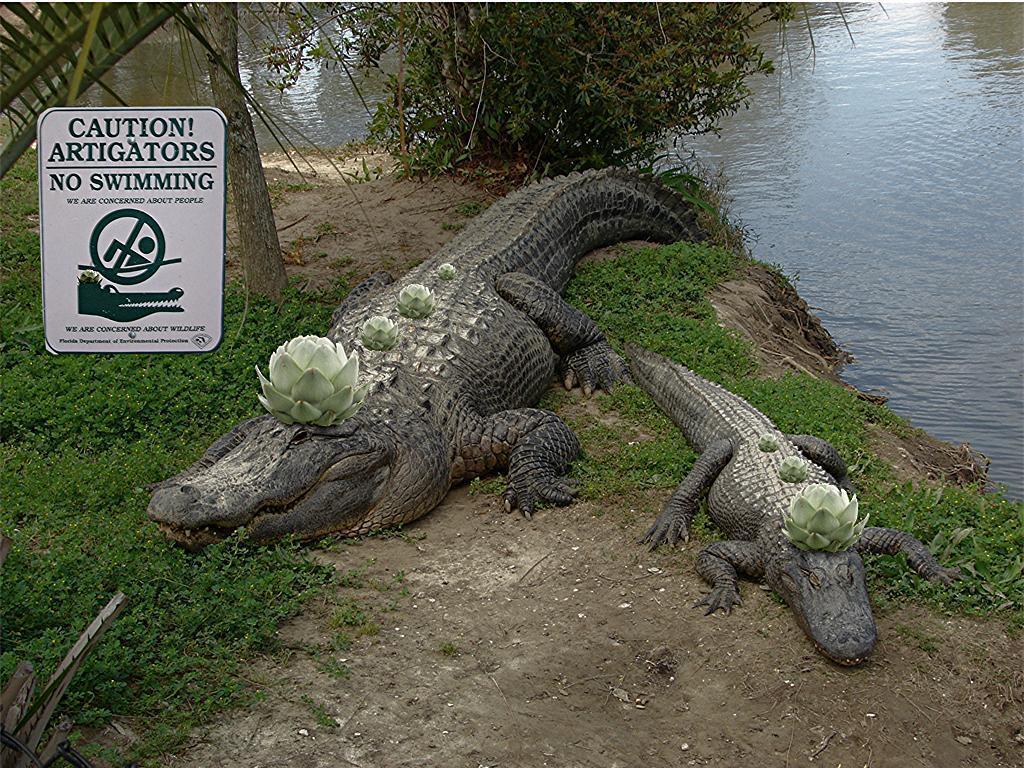Could you give a brief overview of what you see in this image? In this image we can see alligators on the ground, sign board, lake, tree, plants and grass. 